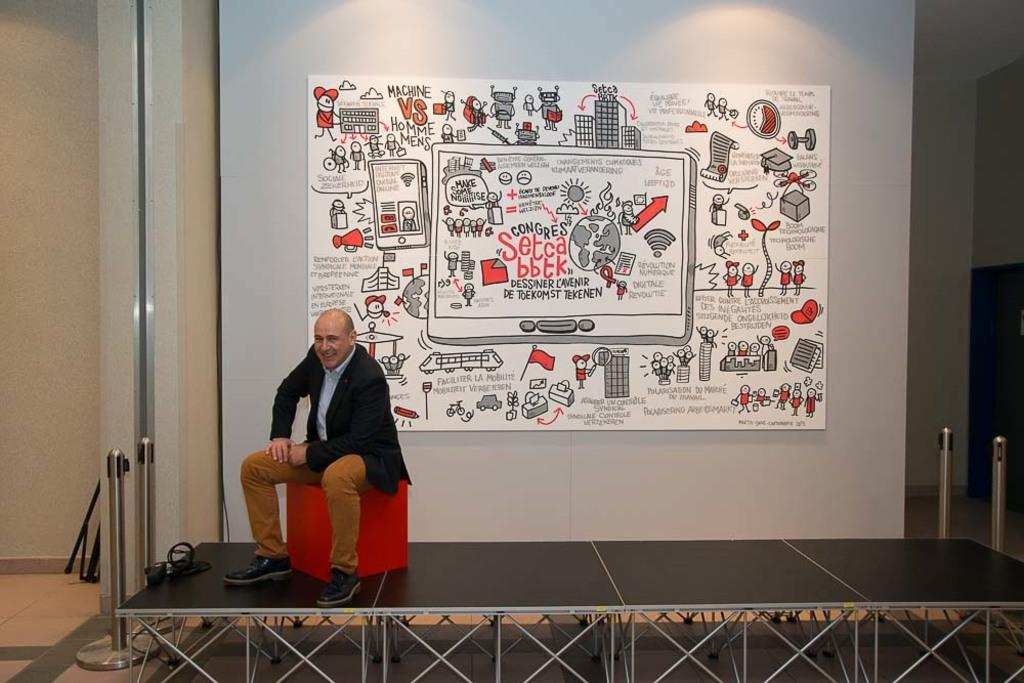What is the man in the image doing? The man is sitting on a stool in the image. What is the man sitting on? The man is sitting on a stool in the image. What can be seen on the stage in the image? There is a device on the stage in the image. What is visible at the back of the image? There is a poster and a wall at the back of the image, along with other objects. What type of wristwatch is the farmer wearing in the image? There is no farmer or wristwatch present in the image. 